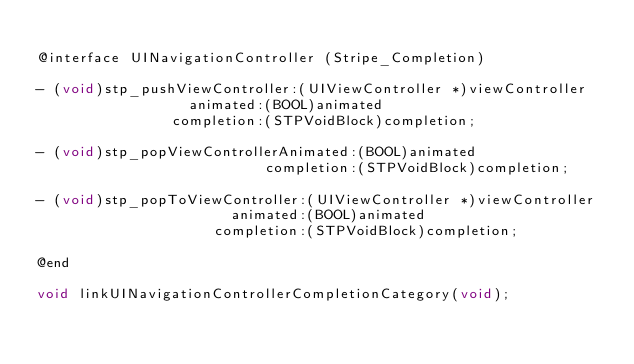<code> <loc_0><loc_0><loc_500><loc_500><_C_>
@interface UINavigationController (Stripe_Completion)

- (void)stp_pushViewController:(UIViewController *)viewController
                  animated:(BOOL)animated
                completion:(STPVoidBlock)completion;

- (void)stp_popViewControllerAnimated:(BOOL)animated
                           completion:(STPVoidBlock)completion;

- (void)stp_popToViewController:(UIViewController *)viewController
                       animated:(BOOL)animated
                     completion:(STPVoidBlock)completion;

@end

void linkUINavigationControllerCompletionCategory(void);
</code> 